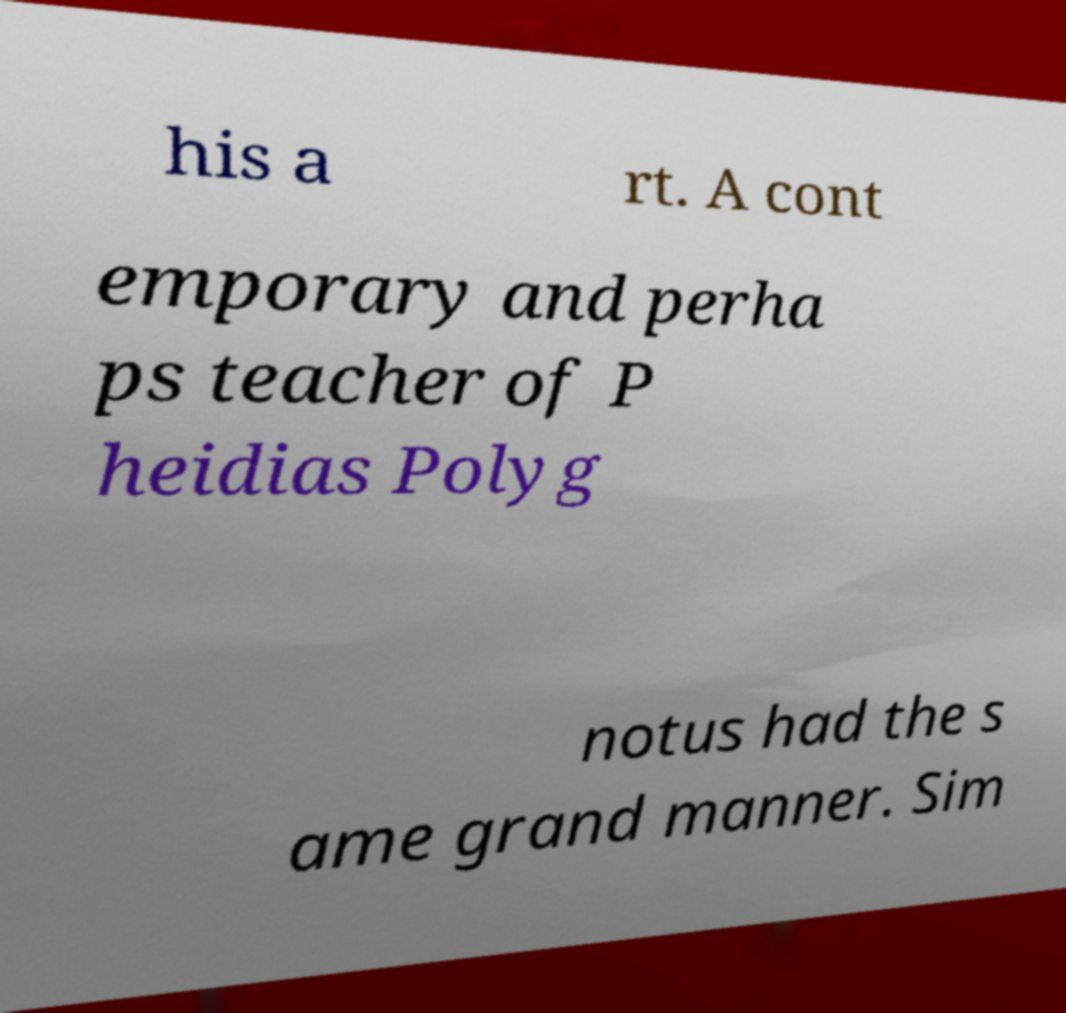Please identify and transcribe the text found in this image. his a rt. A cont emporary and perha ps teacher of P heidias Polyg notus had the s ame grand manner. Sim 